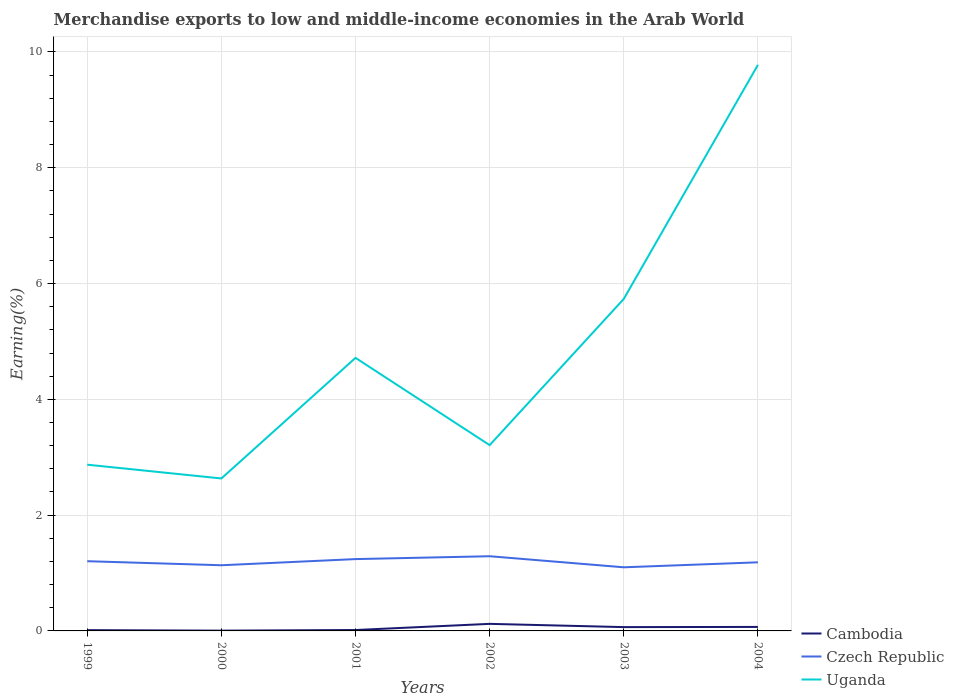How many different coloured lines are there?
Your response must be concise. 3. Is the number of lines equal to the number of legend labels?
Provide a succinct answer. Yes. Across all years, what is the maximum percentage of amount earned from merchandise exports in Czech Republic?
Your response must be concise. 1.1. What is the total percentage of amount earned from merchandise exports in Cambodia in the graph?
Give a very brief answer. -0.06. What is the difference between the highest and the second highest percentage of amount earned from merchandise exports in Uganda?
Provide a short and direct response. 7.14. What is the difference between the highest and the lowest percentage of amount earned from merchandise exports in Czech Republic?
Provide a short and direct response. 3. Is the percentage of amount earned from merchandise exports in Cambodia strictly greater than the percentage of amount earned from merchandise exports in Uganda over the years?
Provide a short and direct response. Yes. Does the graph contain grids?
Keep it short and to the point. Yes. How many legend labels are there?
Your response must be concise. 3. What is the title of the graph?
Make the answer very short. Merchandise exports to low and middle-income economies in the Arab World. What is the label or title of the Y-axis?
Offer a very short reply. Earning(%). What is the Earning(%) of Cambodia in 1999?
Your answer should be very brief. 0.01. What is the Earning(%) in Czech Republic in 1999?
Keep it short and to the point. 1.2. What is the Earning(%) in Uganda in 1999?
Your answer should be compact. 2.87. What is the Earning(%) in Cambodia in 2000?
Your response must be concise. 0. What is the Earning(%) in Czech Republic in 2000?
Provide a short and direct response. 1.13. What is the Earning(%) in Uganda in 2000?
Offer a very short reply. 2.63. What is the Earning(%) in Cambodia in 2001?
Offer a very short reply. 0.02. What is the Earning(%) of Czech Republic in 2001?
Ensure brevity in your answer.  1.24. What is the Earning(%) in Uganda in 2001?
Keep it short and to the point. 4.72. What is the Earning(%) in Cambodia in 2002?
Make the answer very short. 0.12. What is the Earning(%) in Czech Republic in 2002?
Offer a very short reply. 1.29. What is the Earning(%) in Uganda in 2002?
Provide a succinct answer. 3.21. What is the Earning(%) in Cambodia in 2003?
Provide a short and direct response. 0.07. What is the Earning(%) in Czech Republic in 2003?
Ensure brevity in your answer.  1.1. What is the Earning(%) in Uganda in 2003?
Make the answer very short. 5.74. What is the Earning(%) in Cambodia in 2004?
Offer a terse response. 0.07. What is the Earning(%) of Czech Republic in 2004?
Keep it short and to the point. 1.18. What is the Earning(%) in Uganda in 2004?
Offer a terse response. 9.78. Across all years, what is the maximum Earning(%) of Cambodia?
Offer a terse response. 0.12. Across all years, what is the maximum Earning(%) in Czech Republic?
Give a very brief answer. 1.29. Across all years, what is the maximum Earning(%) in Uganda?
Your answer should be compact. 9.78. Across all years, what is the minimum Earning(%) of Cambodia?
Make the answer very short. 0. Across all years, what is the minimum Earning(%) of Czech Republic?
Your response must be concise. 1.1. Across all years, what is the minimum Earning(%) of Uganda?
Your answer should be very brief. 2.63. What is the total Earning(%) in Cambodia in the graph?
Provide a succinct answer. 0.29. What is the total Earning(%) of Czech Republic in the graph?
Your answer should be compact. 7.15. What is the total Earning(%) in Uganda in the graph?
Keep it short and to the point. 28.94. What is the difference between the Earning(%) in Cambodia in 1999 and that in 2000?
Ensure brevity in your answer.  0.01. What is the difference between the Earning(%) in Czech Republic in 1999 and that in 2000?
Keep it short and to the point. 0.07. What is the difference between the Earning(%) in Uganda in 1999 and that in 2000?
Your response must be concise. 0.24. What is the difference between the Earning(%) of Cambodia in 1999 and that in 2001?
Give a very brief answer. -0. What is the difference between the Earning(%) of Czech Republic in 1999 and that in 2001?
Provide a short and direct response. -0.04. What is the difference between the Earning(%) in Uganda in 1999 and that in 2001?
Your response must be concise. -1.85. What is the difference between the Earning(%) in Cambodia in 1999 and that in 2002?
Provide a short and direct response. -0.11. What is the difference between the Earning(%) in Czech Republic in 1999 and that in 2002?
Provide a short and direct response. -0.09. What is the difference between the Earning(%) of Uganda in 1999 and that in 2002?
Offer a terse response. -0.34. What is the difference between the Earning(%) in Cambodia in 1999 and that in 2003?
Your response must be concise. -0.05. What is the difference between the Earning(%) in Czech Republic in 1999 and that in 2003?
Provide a short and direct response. 0.11. What is the difference between the Earning(%) of Uganda in 1999 and that in 2003?
Provide a short and direct response. -2.86. What is the difference between the Earning(%) of Cambodia in 1999 and that in 2004?
Ensure brevity in your answer.  -0.06. What is the difference between the Earning(%) of Czech Republic in 1999 and that in 2004?
Provide a short and direct response. 0.02. What is the difference between the Earning(%) in Uganda in 1999 and that in 2004?
Offer a terse response. -6.91. What is the difference between the Earning(%) of Cambodia in 2000 and that in 2001?
Keep it short and to the point. -0.01. What is the difference between the Earning(%) in Czech Republic in 2000 and that in 2001?
Your response must be concise. -0.11. What is the difference between the Earning(%) of Uganda in 2000 and that in 2001?
Offer a very short reply. -2.08. What is the difference between the Earning(%) of Cambodia in 2000 and that in 2002?
Provide a short and direct response. -0.12. What is the difference between the Earning(%) in Czech Republic in 2000 and that in 2002?
Keep it short and to the point. -0.16. What is the difference between the Earning(%) in Uganda in 2000 and that in 2002?
Provide a succinct answer. -0.58. What is the difference between the Earning(%) in Cambodia in 2000 and that in 2003?
Give a very brief answer. -0.06. What is the difference between the Earning(%) in Czech Republic in 2000 and that in 2003?
Ensure brevity in your answer.  0.04. What is the difference between the Earning(%) in Uganda in 2000 and that in 2003?
Provide a short and direct response. -3.1. What is the difference between the Earning(%) in Cambodia in 2000 and that in 2004?
Provide a succinct answer. -0.06. What is the difference between the Earning(%) of Czech Republic in 2000 and that in 2004?
Offer a terse response. -0.05. What is the difference between the Earning(%) of Uganda in 2000 and that in 2004?
Provide a succinct answer. -7.14. What is the difference between the Earning(%) of Cambodia in 2001 and that in 2002?
Your answer should be very brief. -0.11. What is the difference between the Earning(%) in Czech Republic in 2001 and that in 2002?
Your answer should be compact. -0.05. What is the difference between the Earning(%) in Uganda in 2001 and that in 2002?
Keep it short and to the point. 1.51. What is the difference between the Earning(%) in Cambodia in 2001 and that in 2003?
Ensure brevity in your answer.  -0.05. What is the difference between the Earning(%) in Czech Republic in 2001 and that in 2003?
Provide a succinct answer. 0.14. What is the difference between the Earning(%) in Uganda in 2001 and that in 2003?
Provide a succinct answer. -1.02. What is the difference between the Earning(%) in Cambodia in 2001 and that in 2004?
Ensure brevity in your answer.  -0.05. What is the difference between the Earning(%) in Czech Republic in 2001 and that in 2004?
Provide a succinct answer. 0.06. What is the difference between the Earning(%) of Uganda in 2001 and that in 2004?
Your answer should be compact. -5.06. What is the difference between the Earning(%) in Cambodia in 2002 and that in 2003?
Provide a short and direct response. 0.06. What is the difference between the Earning(%) in Czech Republic in 2002 and that in 2003?
Your answer should be very brief. 0.19. What is the difference between the Earning(%) in Uganda in 2002 and that in 2003?
Your response must be concise. -2.53. What is the difference between the Earning(%) in Cambodia in 2002 and that in 2004?
Your answer should be very brief. 0.05. What is the difference between the Earning(%) of Czech Republic in 2002 and that in 2004?
Your answer should be very brief. 0.11. What is the difference between the Earning(%) of Uganda in 2002 and that in 2004?
Offer a very short reply. -6.57. What is the difference between the Earning(%) in Cambodia in 2003 and that in 2004?
Keep it short and to the point. -0. What is the difference between the Earning(%) in Czech Republic in 2003 and that in 2004?
Keep it short and to the point. -0.09. What is the difference between the Earning(%) of Uganda in 2003 and that in 2004?
Your response must be concise. -4.04. What is the difference between the Earning(%) in Cambodia in 1999 and the Earning(%) in Czech Republic in 2000?
Your response must be concise. -1.12. What is the difference between the Earning(%) of Cambodia in 1999 and the Earning(%) of Uganda in 2000?
Offer a very short reply. -2.62. What is the difference between the Earning(%) in Czech Republic in 1999 and the Earning(%) in Uganda in 2000?
Offer a terse response. -1.43. What is the difference between the Earning(%) in Cambodia in 1999 and the Earning(%) in Czech Republic in 2001?
Your response must be concise. -1.23. What is the difference between the Earning(%) in Cambodia in 1999 and the Earning(%) in Uganda in 2001?
Keep it short and to the point. -4.7. What is the difference between the Earning(%) of Czech Republic in 1999 and the Earning(%) of Uganda in 2001?
Ensure brevity in your answer.  -3.51. What is the difference between the Earning(%) in Cambodia in 1999 and the Earning(%) in Czech Republic in 2002?
Your answer should be very brief. -1.28. What is the difference between the Earning(%) of Cambodia in 1999 and the Earning(%) of Uganda in 2002?
Offer a very short reply. -3.2. What is the difference between the Earning(%) of Czech Republic in 1999 and the Earning(%) of Uganda in 2002?
Ensure brevity in your answer.  -2. What is the difference between the Earning(%) of Cambodia in 1999 and the Earning(%) of Czech Republic in 2003?
Make the answer very short. -1.09. What is the difference between the Earning(%) of Cambodia in 1999 and the Earning(%) of Uganda in 2003?
Your answer should be very brief. -5.72. What is the difference between the Earning(%) in Czech Republic in 1999 and the Earning(%) in Uganda in 2003?
Keep it short and to the point. -4.53. What is the difference between the Earning(%) of Cambodia in 1999 and the Earning(%) of Czech Republic in 2004?
Give a very brief answer. -1.17. What is the difference between the Earning(%) in Cambodia in 1999 and the Earning(%) in Uganda in 2004?
Offer a terse response. -9.76. What is the difference between the Earning(%) of Czech Republic in 1999 and the Earning(%) of Uganda in 2004?
Your response must be concise. -8.57. What is the difference between the Earning(%) of Cambodia in 2000 and the Earning(%) of Czech Republic in 2001?
Keep it short and to the point. -1.24. What is the difference between the Earning(%) of Cambodia in 2000 and the Earning(%) of Uganda in 2001?
Make the answer very short. -4.71. What is the difference between the Earning(%) of Czech Republic in 2000 and the Earning(%) of Uganda in 2001?
Keep it short and to the point. -3.58. What is the difference between the Earning(%) in Cambodia in 2000 and the Earning(%) in Czech Republic in 2002?
Offer a very short reply. -1.29. What is the difference between the Earning(%) of Cambodia in 2000 and the Earning(%) of Uganda in 2002?
Your response must be concise. -3.2. What is the difference between the Earning(%) of Czech Republic in 2000 and the Earning(%) of Uganda in 2002?
Provide a short and direct response. -2.07. What is the difference between the Earning(%) of Cambodia in 2000 and the Earning(%) of Czech Republic in 2003?
Offer a terse response. -1.09. What is the difference between the Earning(%) in Cambodia in 2000 and the Earning(%) in Uganda in 2003?
Offer a terse response. -5.73. What is the difference between the Earning(%) of Czech Republic in 2000 and the Earning(%) of Uganda in 2003?
Provide a succinct answer. -4.6. What is the difference between the Earning(%) in Cambodia in 2000 and the Earning(%) in Czech Republic in 2004?
Give a very brief answer. -1.18. What is the difference between the Earning(%) of Cambodia in 2000 and the Earning(%) of Uganda in 2004?
Make the answer very short. -9.77. What is the difference between the Earning(%) in Czech Republic in 2000 and the Earning(%) in Uganda in 2004?
Your response must be concise. -8.64. What is the difference between the Earning(%) in Cambodia in 2001 and the Earning(%) in Czech Republic in 2002?
Your response must be concise. -1.27. What is the difference between the Earning(%) in Cambodia in 2001 and the Earning(%) in Uganda in 2002?
Give a very brief answer. -3.19. What is the difference between the Earning(%) of Czech Republic in 2001 and the Earning(%) of Uganda in 2002?
Provide a short and direct response. -1.97. What is the difference between the Earning(%) of Cambodia in 2001 and the Earning(%) of Czech Republic in 2003?
Give a very brief answer. -1.08. What is the difference between the Earning(%) in Cambodia in 2001 and the Earning(%) in Uganda in 2003?
Offer a very short reply. -5.72. What is the difference between the Earning(%) of Czech Republic in 2001 and the Earning(%) of Uganda in 2003?
Ensure brevity in your answer.  -4.49. What is the difference between the Earning(%) of Cambodia in 2001 and the Earning(%) of Czech Republic in 2004?
Your answer should be compact. -1.17. What is the difference between the Earning(%) in Cambodia in 2001 and the Earning(%) in Uganda in 2004?
Offer a terse response. -9.76. What is the difference between the Earning(%) in Czech Republic in 2001 and the Earning(%) in Uganda in 2004?
Ensure brevity in your answer.  -8.54. What is the difference between the Earning(%) in Cambodia in 2002 and the Earning(%) in Czech Republic in 2003?
Make the answer very short. -0.98. What is the difference between the Earning(%) in Cambodia in 2002 and the Earning(%) in Uganda in 2003?
Keep it short and to the point. -5.61. What is the difference between the Earning(%) in Czech Republic in 2002 and the Earning(%) in Uganda in 2003?
Your answer should be compact. -4.45. What is the difference between the Earning(%) of Cambodia in 2002 and the Earning(%) of Czech Republic in 2004?
Offer a very short reply. -1.06. What is the difference between the Earning(%) of Cambodia in 2002 and the Earning(%) of Uganda in 2004?
Make the answer very short. -9.66. What is the difference between the Earning(%) of Czech Republic in 2002 and the Earning(%) of Uganda in 2004?
Offer a very short reply. -8.49. What is the difference between the Earning(%) of Cambodia in 2003 and the Earning(%) of Czech Republic in 2004?
Offer a terse response. -1.12. What is the difference between the Earning(%) in Cambodia in 2003 and the Earning(%) in Uganda in 2004?
Your answer should be very brief. -9.71. What is the difference between the Earning(%) of Czech Republic in 2003 and the Earning(%) of Uganda in 2004?
Offer a terse response. -8.68. What is the average Earning(%) in Cambodia per year?
Make the answer very short. 0.05. What is the average Earning(%) in Czech Republic per year?
Your answer should be very brief. 1.19. What is the average Earning(%) in Uganda per year?
Keep it short and to the point. 4.82. In the year 1999, what is the difference between the Earning(%) in Cambodia and Earning(%) in Czech Republic?
Offer a terse response. -1.19. In the year 1999, what is the difference between the Earning(%) in Cambodia and Earning(%) in Uganda?
Your response must be concise. -2.86. In the year 1999, what is the difference between the Earning(%) of Czech Republic and Earning(%) of Uganda?
Ensure brevity in your answer.  -1.67. In the year 2000, what is the difference between the Earning(%) in Cambodia and Earning(%) in Czech Republic?
Offer a very short reply. -1.13. In the year 2000, what is the difference between the Earning(%) of Cambodia and Earning(%) of Uganda?
Provide a short and direct response. -2.63. In the year 2000, what is the difference between the Earning(%) in Czech Republic and Earning(%) in Uganda?
Your answer should be compact. -1.5. In the year 2001, what is the difference between the Earning(%) of Cambodia and Earning(%) of Czech Republic?
Provide a short and direct response. -1.22. In the year 2001, what is the difference between the Earning(%) in Cambodia and Earning(%) in Uganda?
Ensure brevity in your answer.  -4.7. In the year 2001, what is the difference between the Earning(%) in Czech Republic and Earning(%) in Uganda?
Provide a succinct answer. -3.48. In the year 2002, what is the difference between the Earning(%) of Cambodia and Earning(%) of Czech Republic?
Ensure brevity in your answer.  -1.17. In the year 2002, what is the difference between the Earning(%) in Cambodia and Earning(%) in Uganda?
Provide a succinct answer. -3.09. In the year 2002, what is the difference between the Earning(%) of Czech Republic and Earning(%) of Uganda?
Provide a succinct answer. -1.92. In the year 2003, what is the difference between the Earning(%) of Cambodia and Earning(%) of Czech Republic?
Provide a succinct answer. -1.03. In the year 2003, what is the difference between the Earning(%) of Cambodia and Earning(%) of Uganda?
Give a very brief answer. -5.67. In the year 2003, what is the difference between the Earning(%) in Czech Republic and Earning(%) in Uganda?
Your answer should be compact. -4.64. In the year 2004, what is the difference between the Earning(%) in Cambodia and Earning(%) in Czech Republic?
Offer a terse response. -1.12. In the year 2004, what is the difference between the Earning(%) in Cambodia and Earning(%) in Uganda?
Offer a very short reply. -9.71. In the year 2004, what is the difference between the Earning(%) of Czech Republic and Earning(%) of Uganda?
Your response must be concise. -8.59. What is the ratio of the Earning(%) of Cambodia in 1999 to that in 2000?
Keep it short and to the point. 2.79. What is the ratio of the Earning(%) in Czech Republic in 1999 to that in 2000?
Provide a succinct answer. 1.06. What is the ratio of the Earning(%) in Uganda in 1999 to that in 2000?
Your answer should be compact. 1.09. What is the ratio of the Earning(%) in Cambodia in 1999 to that in 2001?
Offer a terse response. 0.86. What is the ratio of the Earning(%) of Czech Republic in 1999 to that in 2001?
Offer a very short reply. 0.97. What is the ratio of the Earning(%) of Uganda in 1999 to that in 2001?
Keep it short and to the point. 0.61. What is the ratio of the Earning(%) of Cambodia in 1999 to that in 2002?
Your answer should be compact. 0.11. What is the ratio of the Earning(%) in Czech Republic in 1999 to that in 2002?
Your answer should be very brief. 0.93. What is the ratio of the Earning(%) in Uganda in 1999 to that in 2002?
Ensure brevity in your answer.  0.89. What is the ratio of the Earning(%) in Cambodia in 1999 to that in 2003?
Your response must be concise. 0.2. What is the ratio of the Earning(%) of Czech Republic in 1999 to that in 2003?
Keep it short and to the point. 1.1. What is the ratio of the Earning(%) in Uganda in 1999 to that in 2003?
Make the answer very short. 0.5. What is the ratio of the Earning(%) in Cambodia in 1999 to that in 2004?
Your answer should be compact. 0.19. What is the ratio of the Earning(%) in Czech Republic in 1999 to that in 2004?
Provide a succinct answer. 1.02. What is the ratio of the Earning(%) of Uganda in 1999 to that in 2004?
Your answer should be very brief. 0.29. What is the ratio of the Earning(%) in Cambodia in 2000 to that in 2001?
Make the answer very short. 0.31. What is the ratio of the Earning(%) in Czech Republic in 2000 to that in 2001?
Your answer should be compact. 0.91. What is the ratio of the Earning(%) of Uganda in 2000 to that in 2001?
Provide a succinct answer. 0.56. What is the ratio of the Earning(%) in Cambodia in 2000 to that in 2002?
Provide a short and direct response. 0.04. What is the ratio of the Earning(%) in Czech Republic in 2000 to that in 2002?
Make the answer very short. 0.88. What is the ratio of the Earning(%) of Uganda in 2000 to that in 2002?
Ensure brevity in your answer.  0.82. What is the ratio of the Earning(%) of Cambodia in 2000 to that in 2003?
Your answer should be very brief. 0.07. What is the ratio of the Earning(%) of Czech Republic in 2000 to that in 2003?
Make the answer very short. 1.03. What is the ratio of the Earning(%) in Uganda in 2000 to that in 2003?
Keep it short and to the point. 0.46. What is the ratio of the Earning(%) of Cambodia in 2000 to that in 2004?
Provide a short and direct response. 0.07. What is the ratio of the Earning(%) of Czech Republic in 2000 to that in 2004?
Give a very brief answer. 0.96. What is the ratio of the Earning(%) of Uganda in 2000 to that in 2004?
Your answer should be very brief. 0.27. What is the ratio of the Earning(%) in Cambodia in 2001 to that in 2002?
Your answer should be very brief. 0.13. What is the ratio of the Earning(%) in Czech Republic in 2001 to that in 2002?
Your response must be concise. 0.96. What is the ratio of the Earning(%) of Uganda in 2001 to that in 2002?
Keep it short and to the point. 1.47. What is the ratio of the Earning(%) of Cambodia in 2001 to that in 2003?
Provide a succinct answer. 0.24. What is the ratio of the Earning(%) of Czech Republic in 2001 to that in 2003?
Ensure brevity in your answer.  1.13. What is the ratio of the Earning(%) in Uganda in 2001 to that in 2003?
Ensure brevity in your answer.  0.82. What is the ratio of the Earning(%) of Cambodia in 2001 to that in 2004?
Ensure brevity in your answer.  0.23. What is the ratio of the Earning(%) in Czech Republic in 2001 to that in 2004?
Offer a very short reply. 1.05. What is the ratio of the Earning(%) of Uganda in 2001 to that in 2004?
Give a very brief answer. 0.48. What is the ratio of the Earning(%) of Cambodia in 2002 to that in 2003?
Provide a succinct answer. 1.85. What is the ratio of the Earning(%) in Czech Republic in 2002 to that in 2003?
Provide a short and direct response. 1.17. What is the ratio of the Earning(%) in Uganda in 2002 to that in 2003?
Your response must be concise. 0.56. What is the ratio of the Earning(%) of Cambodia in 2002 to that in 2004?
Offer a very short reply. 1.76. What is the ratio of the Earning(%) of Czech Republic in 2002 to that in 2004?
Provide a succinct answer. 1.09. What is the ratio of the Earning(%) of Uganda in 2002 to that in 2004?
Make the answer very short. 0.33. What is the ratio of the Earning(%) in Cambodia in 2003 to that in 2004?
Keep it short and to the point. 0.95. What is the ratio of the Earning(%) in Czech Republic in 2003 to that in 2004?
Give a very brief answer. 0.93. What is the ratio of the Earning(%) in Uganda in 2003 to that in 2004?
Your answer should be very brief. 0.59. What is the difference between the highest and the second highest Earning(%) in Cambodia?
Your response must be concise. 0.05. What is the difference between the highest and the second highest Earning(%) of Czech Republic?
Your answer should be compact. 0.05. What is the difference between the highest and the second highest Earning(%) in Uganda?
Offer a terse response. 4.04. What is the difference between the highest and the lowest Earning(%) of Cambodia?
Offer a terse response. 0.12. What is the difference between the highest and the lowest Earning(%) in Czech Republic?
Your response must be concise. 0.19. What is the difference between the highest and the lowest Earning(%) of Uganda?
Offer a very short reply. 7.14. 